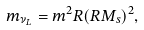Convert formula to latex. <formula><loc_0><loc_0><loc_500><loc_500>m _ { \nu _ { L } } = m ^ { 2 } R ( R M _ { s } ) ^ { 2 } ,</formula> 